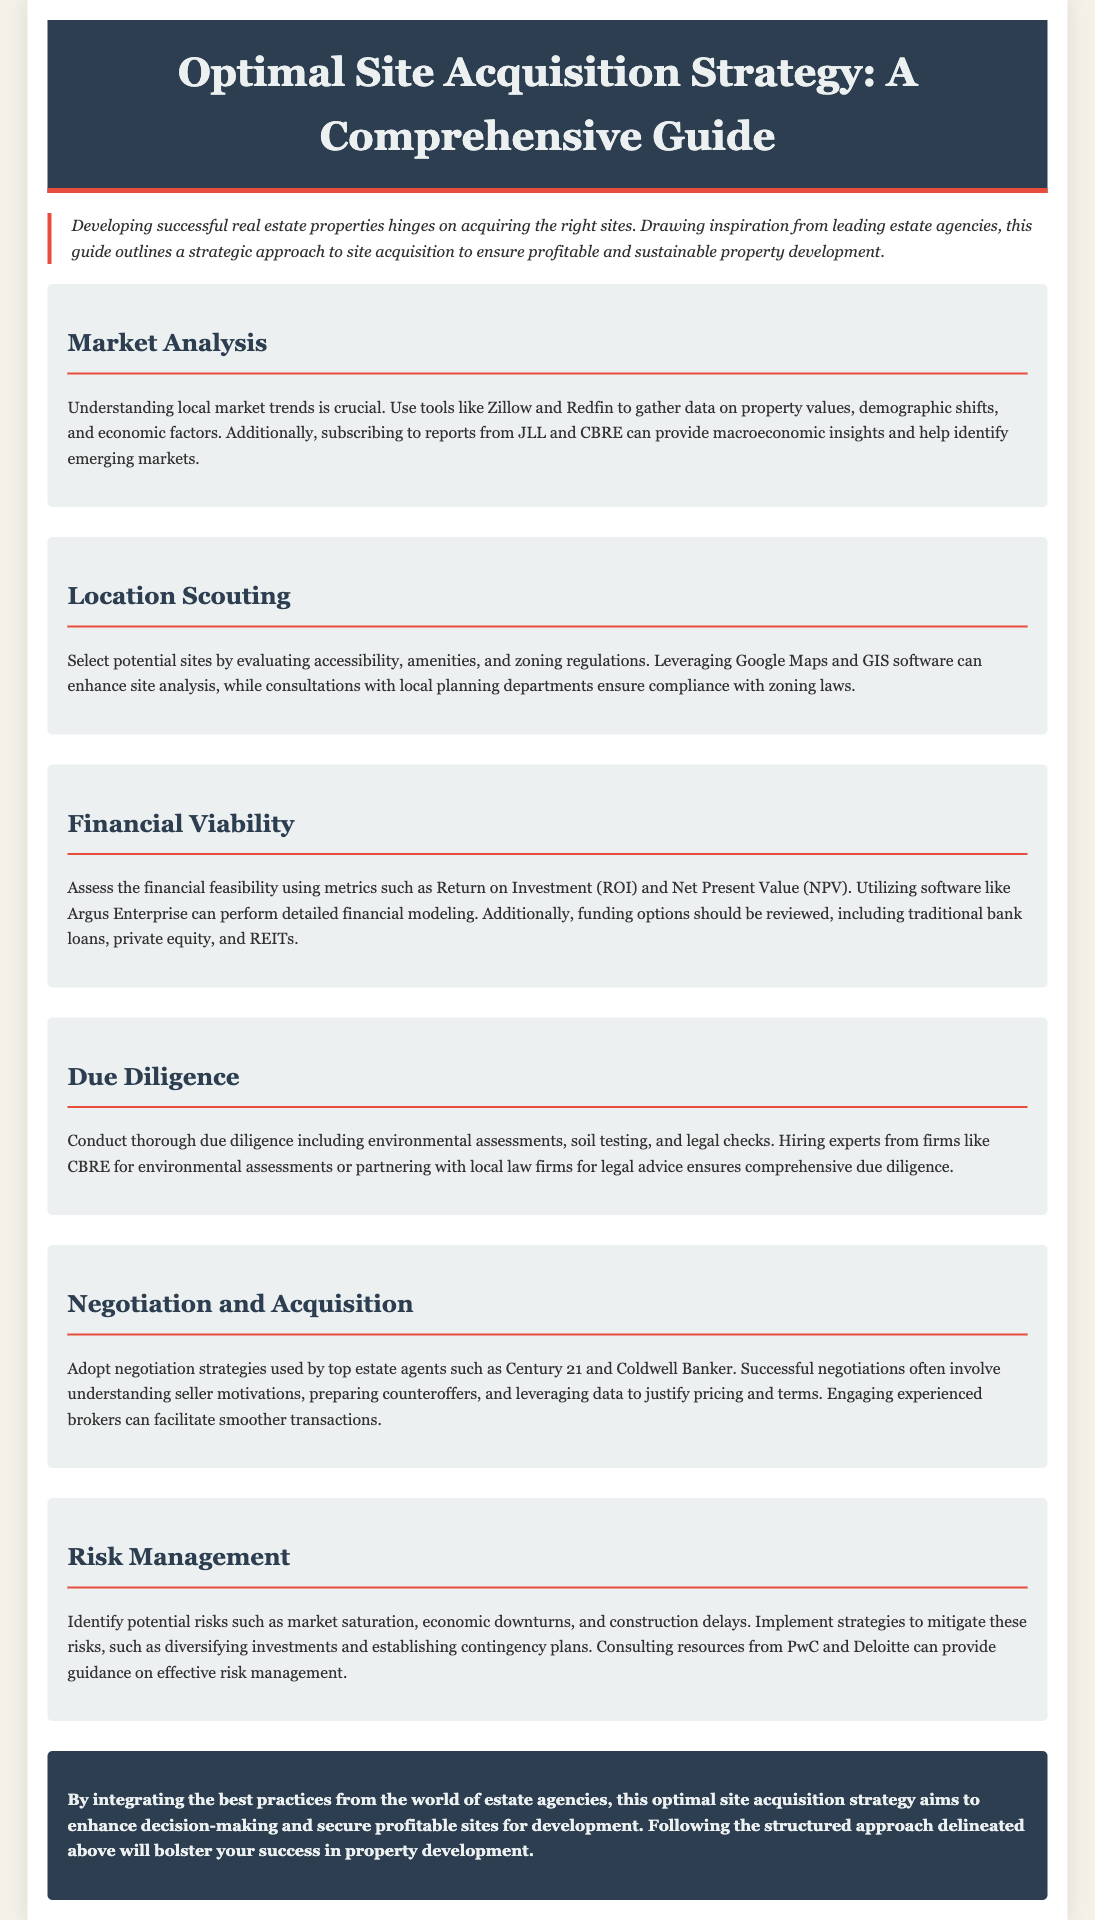What is the title of the proposal? The title of the proposal is stated in the header of the document.
Answer: Optimal Site Acquisition Strategy: A Comprehensive Guide What is the purpose of the guide? The purpose is outlined in the introduction, highlighting the need for a strategic approach in site acquisition.
Answer: To ensure profitable and sustainable property development Which tool is recommended for market analysis? The document mentions specific tools that can provide data for market analysis.
Answer: Zillow What metrics should be assessed for financial viability? The proposal specifies metrics that are crucial in analyzing financial feasibility.
Answer: Return on Investment (ROI) and Net Present Value (NPV) What type of assessments are included in due diligence? The section on due diligence lists several types of assessments needed before acquiring a site.
Answer: Environmental assessments, soil testing, and legal checks Which estate agencies' negotiation strategies are mentioned? The proposal refers to specific estate agencies known for effective negotiation strategies.
Answer: Century 21 and Coldwell Banker What is a potential risk mentioned in risk management? The document lists various risks that property developers may face.
Answer: Market saturation What software is suggested for financial modeling? The proposal recommends a specific software application for detailed financial modeling.
Answer: Argus Enterprise What should be evaluated when selecting potential sites? The factors one needs to consider are outlined under location scouting.
Answer: Accessibility, amenities, and zoning regulations 